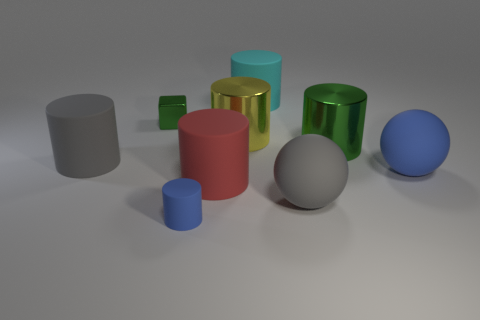Subtract all green cylinders. How many cylinders are left? 5 Subtract all big gray matte cylinders. How many cylinders are left? 5 Subtract all green cylinders. Subtract all green spheres. How many cylinders are left? 5 Add 1 tiny red rubber cylinders. How many objects exist? 10 Subtract all blocks. How many objects are left? 8 Subtract all tiny green blocks. Subtract all cyan metallic cubes. How many objects are left? 8 Add 1 red cylinders. How many red cylinders are left? 2 Add 8 blue objects. How many blue objects exist? 10 Subtract 1 green blocks. How many objects are left? 8 